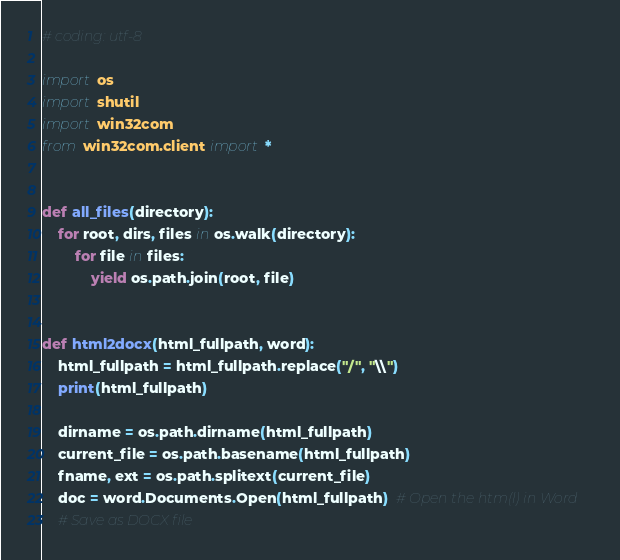Convert code to text. <code><loc_0><loc_0><loc_500><loc_500><_Python_># coding: utf-8

import os
import shutil
import win32com
from win32com.client import *


def all_files(directory):
    for root, dirs, files in os.walk(directory):
        for file in files:
            yield os.path.join(root, file)


def html2docx(html_fullpath, word):
    html_fullpath = html_fullpath.replace("/", "\\")
    print(html_fullpath)

    dirname = os.path.dirname(html_fullpath)
    current_file = os.path.basename(html_fullpath)
    fname, ext = os.path.splitext(current_file)
    doc = word.Documents.Open(html_fullpath)  # Open the htm(l) in Word
    # Save as DOCX file</code> 